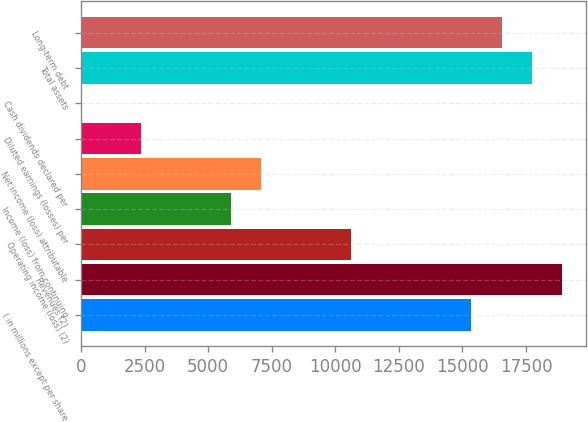Convert chart to OTSL. <chart><loc_0><loc_0><loc_500><loc_500><bar_chart><fcel>( in millions except per share<fcel>Revenues (2)<fcel>Operating income (loss) (2)<fcel>Income (loss) from continuing<fcel>Net income (loss) attributable<fcel>Diluted earnings (losses) per<fcel>Cash dividends declared per<fcel>Total assets<fcel>Long-term debt<nl><fcel>15358<fcel>18902.1<fcel>10632.6<fcel>5907.24<fcel>7088.59<fcel>2363.19<fcel>0.49<fcel>17720.7<fcel>16539.4<nl></chart> 